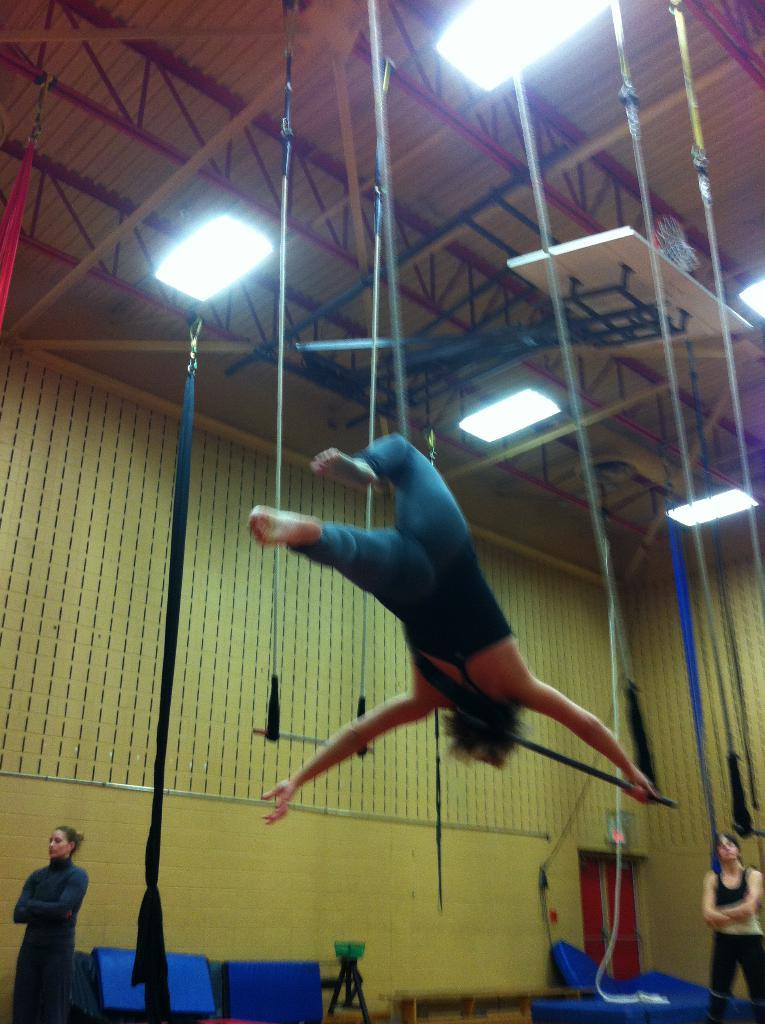How many ladies are present in the image? There are two ladies standing in the image. What are the ladies doing in the image? The ladies are standing on a floor. What can be seen in the background of the image? There is a wall in the background of the image. What is the lady at the top of the image doing? A lady is performing gymnastics with ropes at the top of the image. What can be seen illuminating the scene in the image? There are lights visible in the image. What type of wrench is the lady using to control the flames in the image? There is no wrench or flames present in the image. 